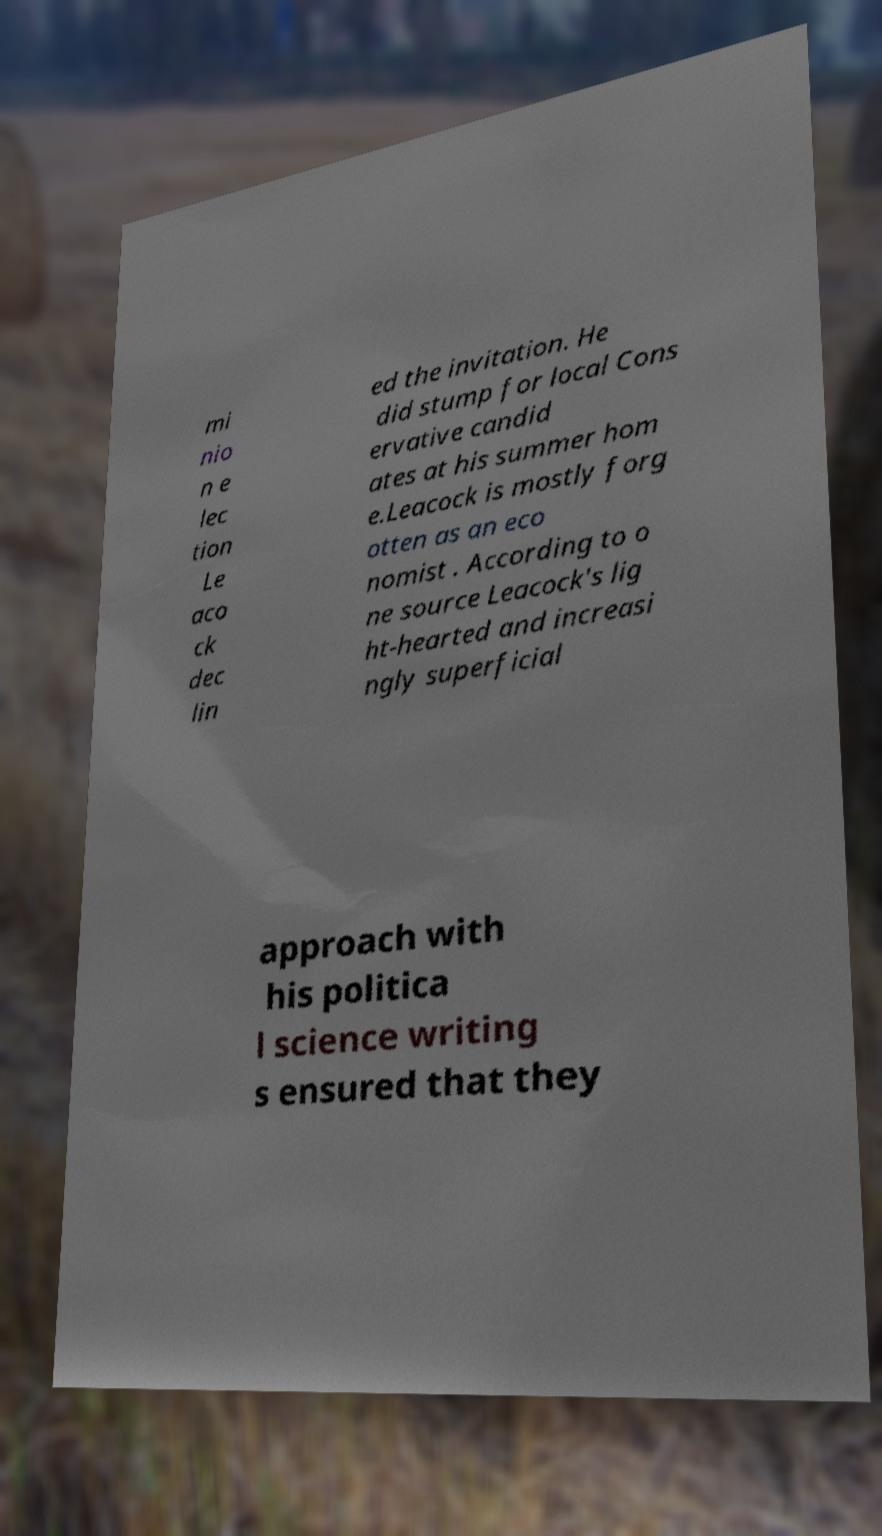Could you assist in decoding the text presented in this image and type it out clearly? mi nio n e lec tion Le aco ck dec lin ed the invitation. He did stump for local Cons ervative candid ates at his summer hom e.Leacock is mostly forg otten as an eco nomist . According to o ne source Leacock's lig ht-hearted and increasi ngly superficial approach with his politica l science writing s ensured that they 